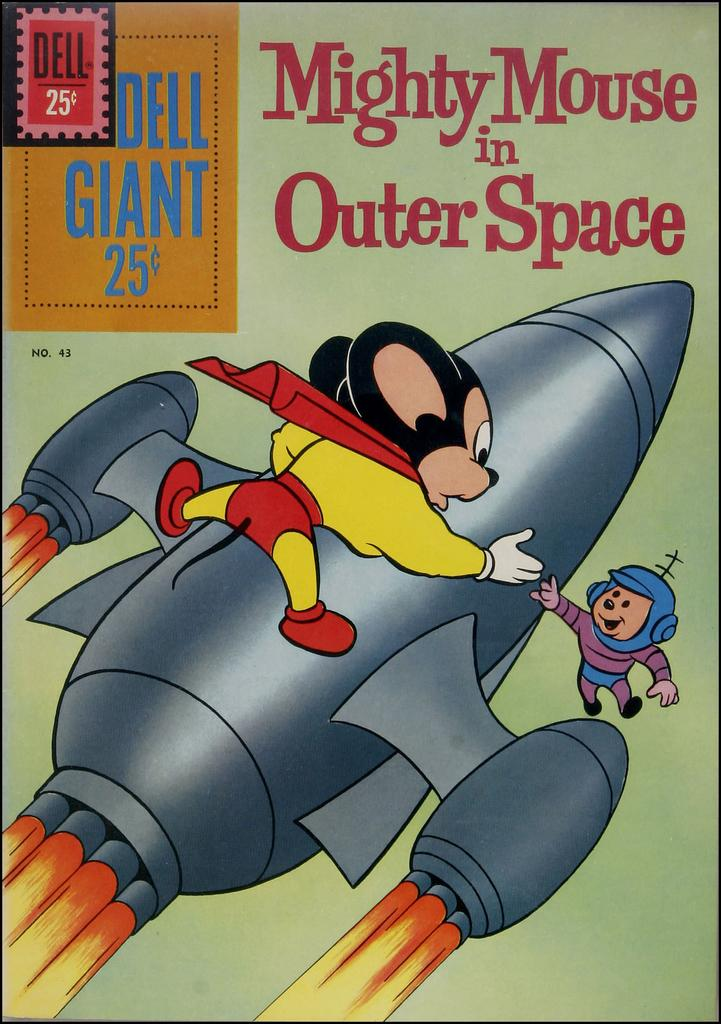What type of characters are depicted in the image? There is a cartoon picture of mice and an aeroplane in the image. What can be found at the top of the image? There is text at the top of the image. How many apples are being blown by the wind in the image? There are no apples or wind present in the image; it features cartoon pictures of mice and an aeroplane with text at the top. 